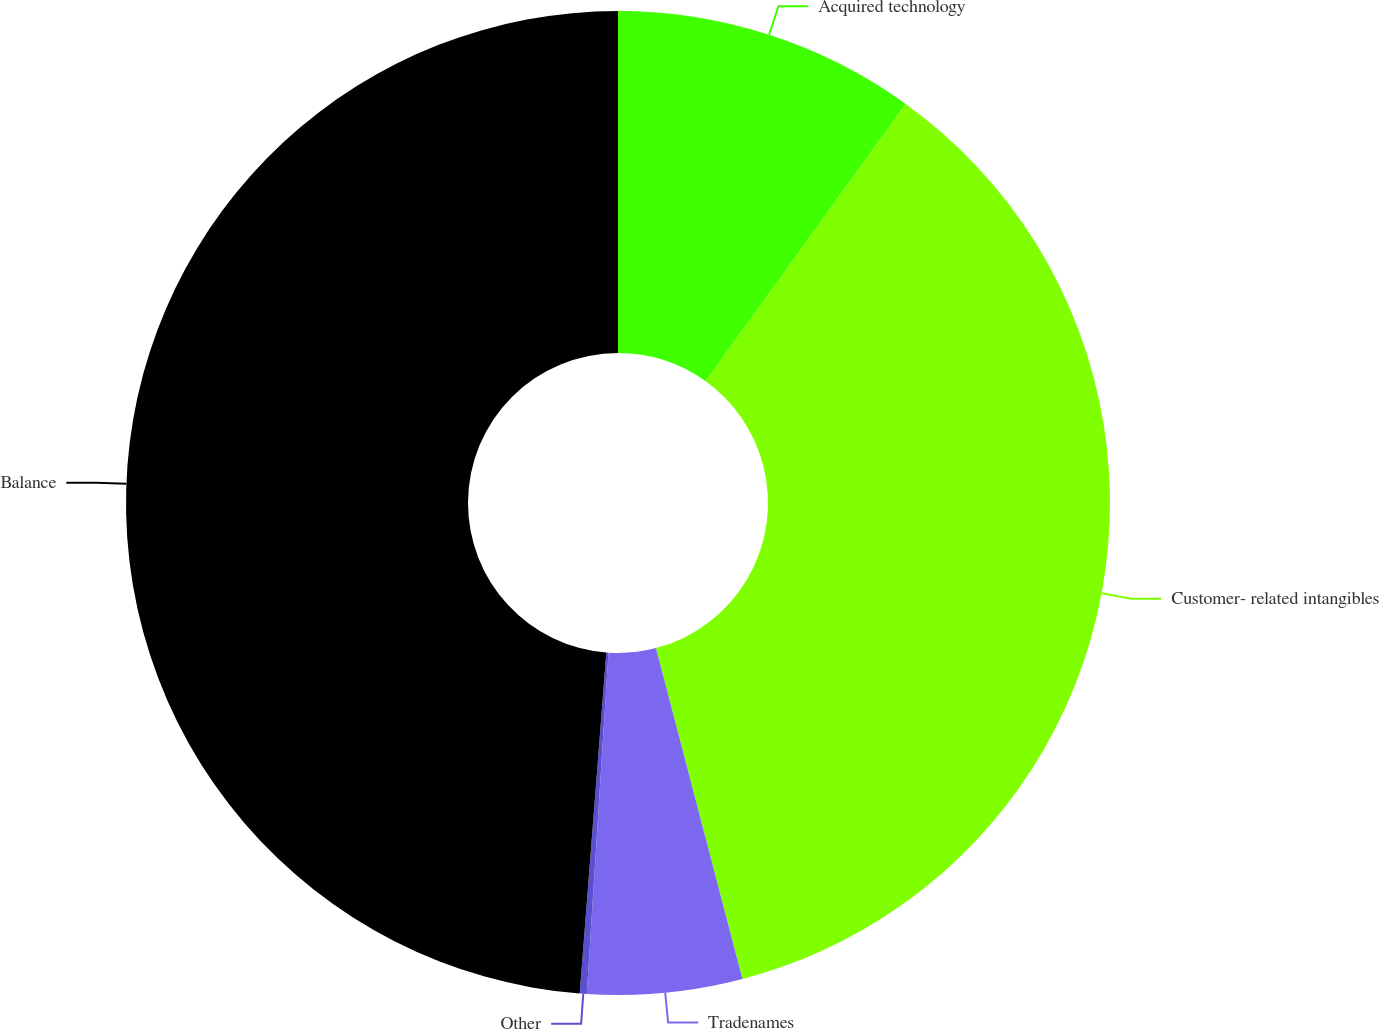<chart> <loc_0><loc_0><loc_500><loc_500><pie_chart><fcel>Acquired technology<fcel>Customer- related intangibles<fcel>Tradenames<fcel>Other<fcel>Balance<nl><fcel>9.94%<fcel>35.99%<fcel>5.08%<fcel>0.23%<fcel>48.76%<nl></chart> 